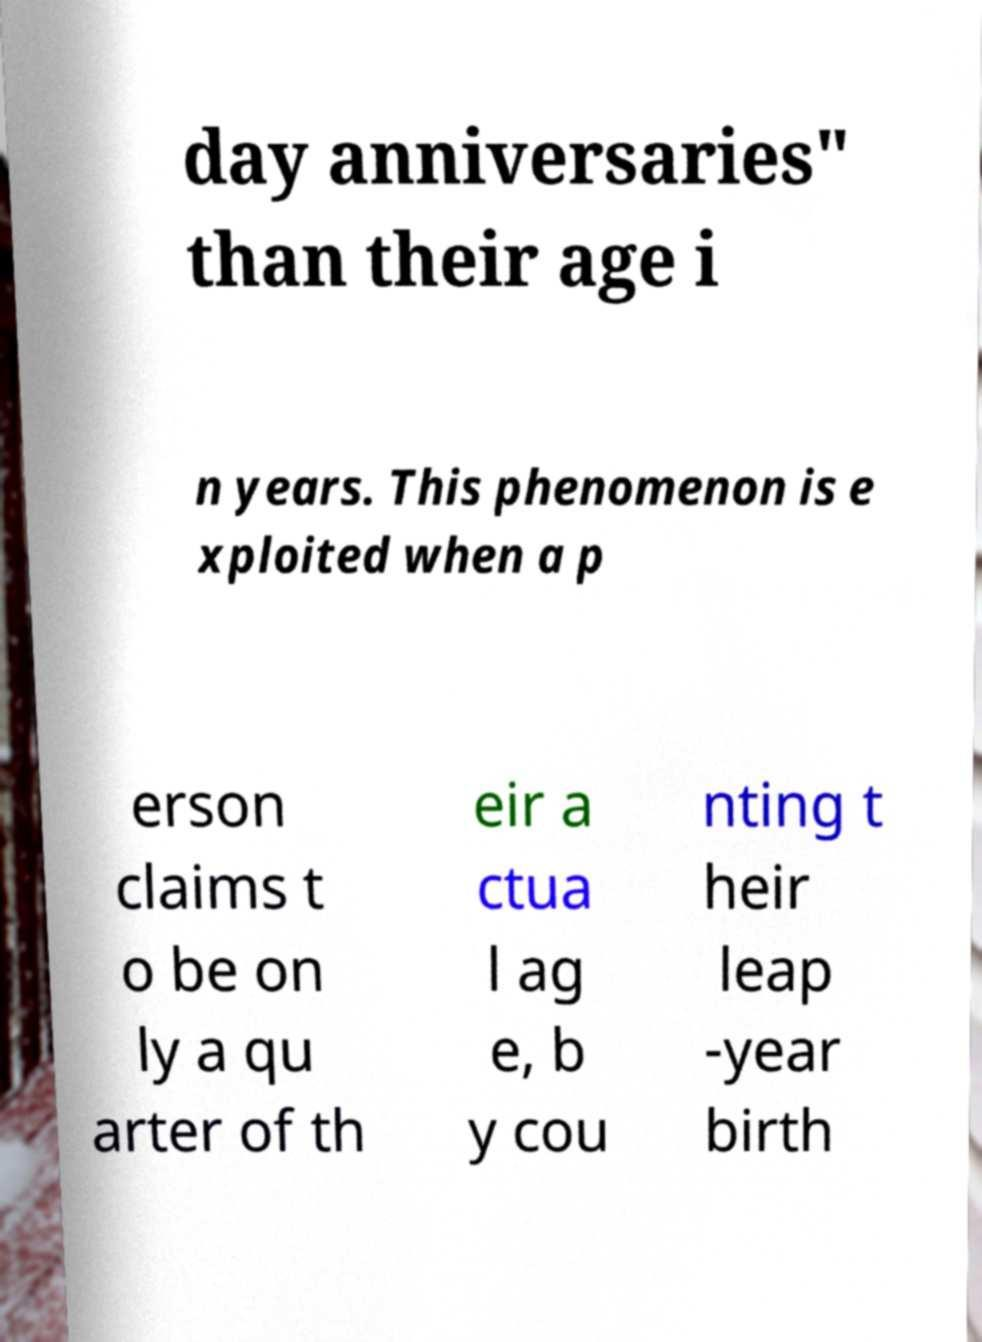What messages or text are displayed in this image? I need them in a readable, typed format. day anniversaries" than their age i n years. This phenomenon is e xploited when a p erson claims t o be on ly a qu arter of th eir a ctua l ag e, b y cou nting t heir leap -year birth 